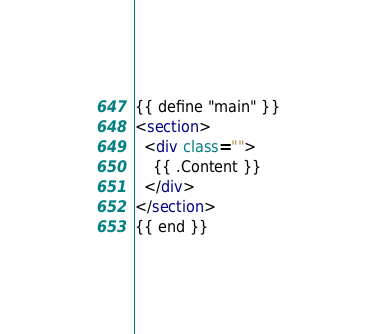Convert code to text. <code><loc_0><loc_0><loc_500><loc_500><_HTML_>{{ define "main" }}
<section>
  <div class="">
    {{ .Content }}
  </div>
</section>
{{ end }}
</code> 